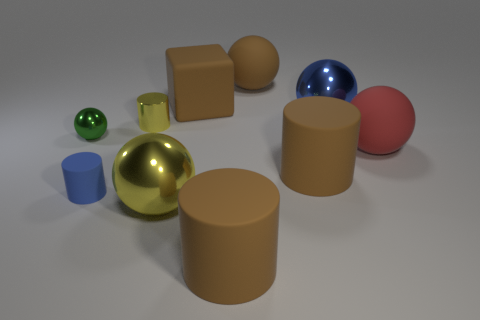Subtract all large red spheres. How many spheres are left? 4 Subtract all green balls. How many brown cylinders are left? 2 Subtract all yellow spheres. How many spheres are left? 4 Subtract all cylinders. How many objects are left? 6 Subtract 0 purple cylinders. How many objects are left? 10 Subtract 2 cylinders. How many cylinders are left? 2 Subtract all red cylinders. Subtract all gray blocks. How many cylinders are left? 4 Subtract all brown rubber cubes. Subtract all small matte things. How many objects are left? 8 Add 5 big rubber spheres. How many big rubber spheres are left? 7 Add 8 tiny purple metal balls. How many tiny purple metal balls exist? 8 